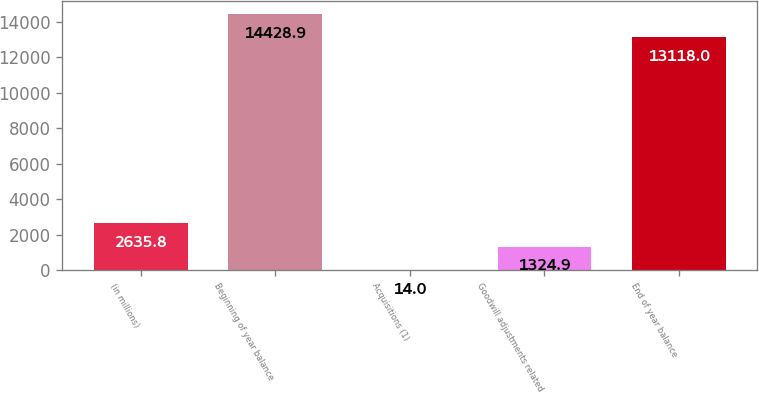<chart> <loc_0><loc_0><loc_500><loc_500><bar_chart><fcel>(in millions)<fcel>Beginning of year balance<fcel>Acquisitions (1)<fcel>Goodwill adjustments related<fcel>End of year balance<nl><fcel>2635.8<fcel>14428.9<fcel>14<fcel>1324.9<fcel>13118<nl></chart> 